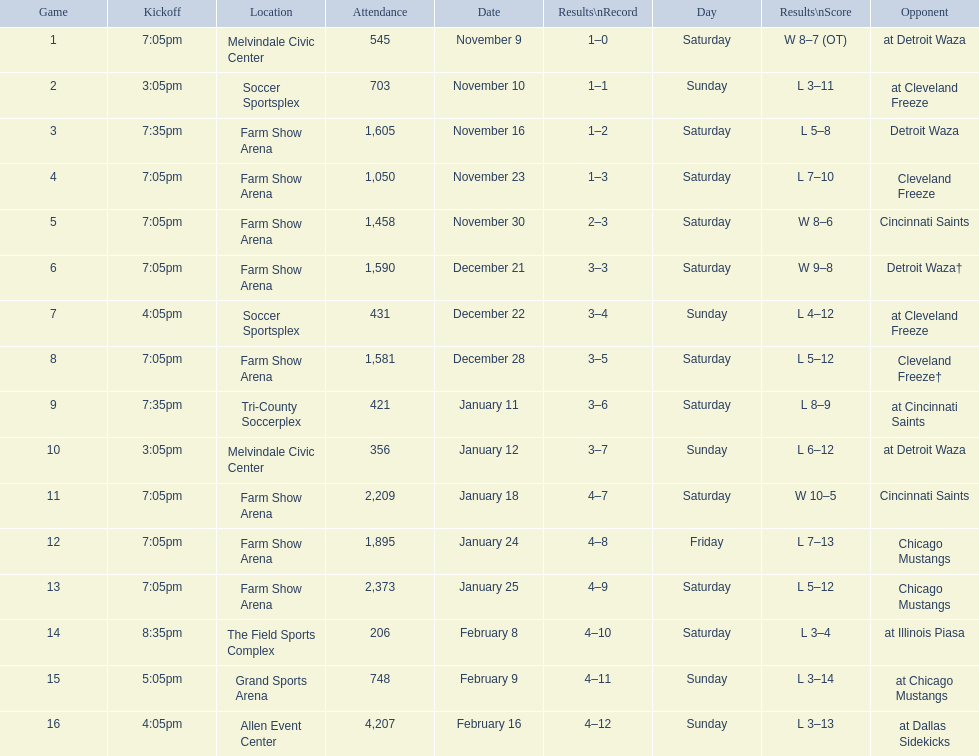Which competitor appears first in the table? Detroit Waza. 